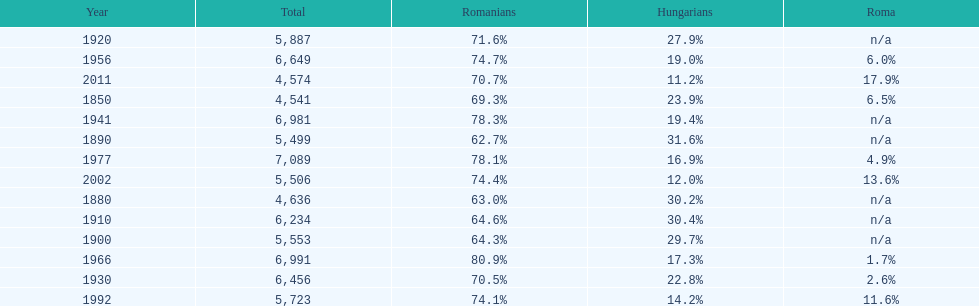Which year had a total of 6,981 and 19.4% hungarians? 1941. Help me parse the entirety of this table. {'header': ['Year', 'Total', 'Romanians', 'Hungarians', 'Roma'], 'rows': [['1920', '5,887', '71.6%', '27.9%', 'n/a'], ['1956', '6,649', '74.7%', '19.0%', '6.0%'], ['2011', '4,574', '70.7%', '11.2%', '17.9%'], ['1850', '4,541', '69.3%', '23.9%', '6.5%'], ['1941', '6,981', '78.3%', '19.4%', 'n/a'], ['1890', '5,499', '62.7%', '31.6%', 'n/a'], ['1977', '7,089', '78.1%', '16.9%', '4.9%'], ['2002', '5,506', '74.4%', '12.0%', '13.6%'], ['1880', '4,636', '63.0%', '30.2%', 'n/a'], ['1910', '6,234', '64.6%', '30.4%', 'n/a'], ['1900', '5,553', '64.3%', '29.7%', 'n/a'], ['1966', '6,991', '80.9%', '17.3%', '1.7%'], ['1930', '6,456', '70.5%', '22.8%', '2.6%'], ['1992', '5,723', '74.1%', '14.2%', '11.6%']]} 